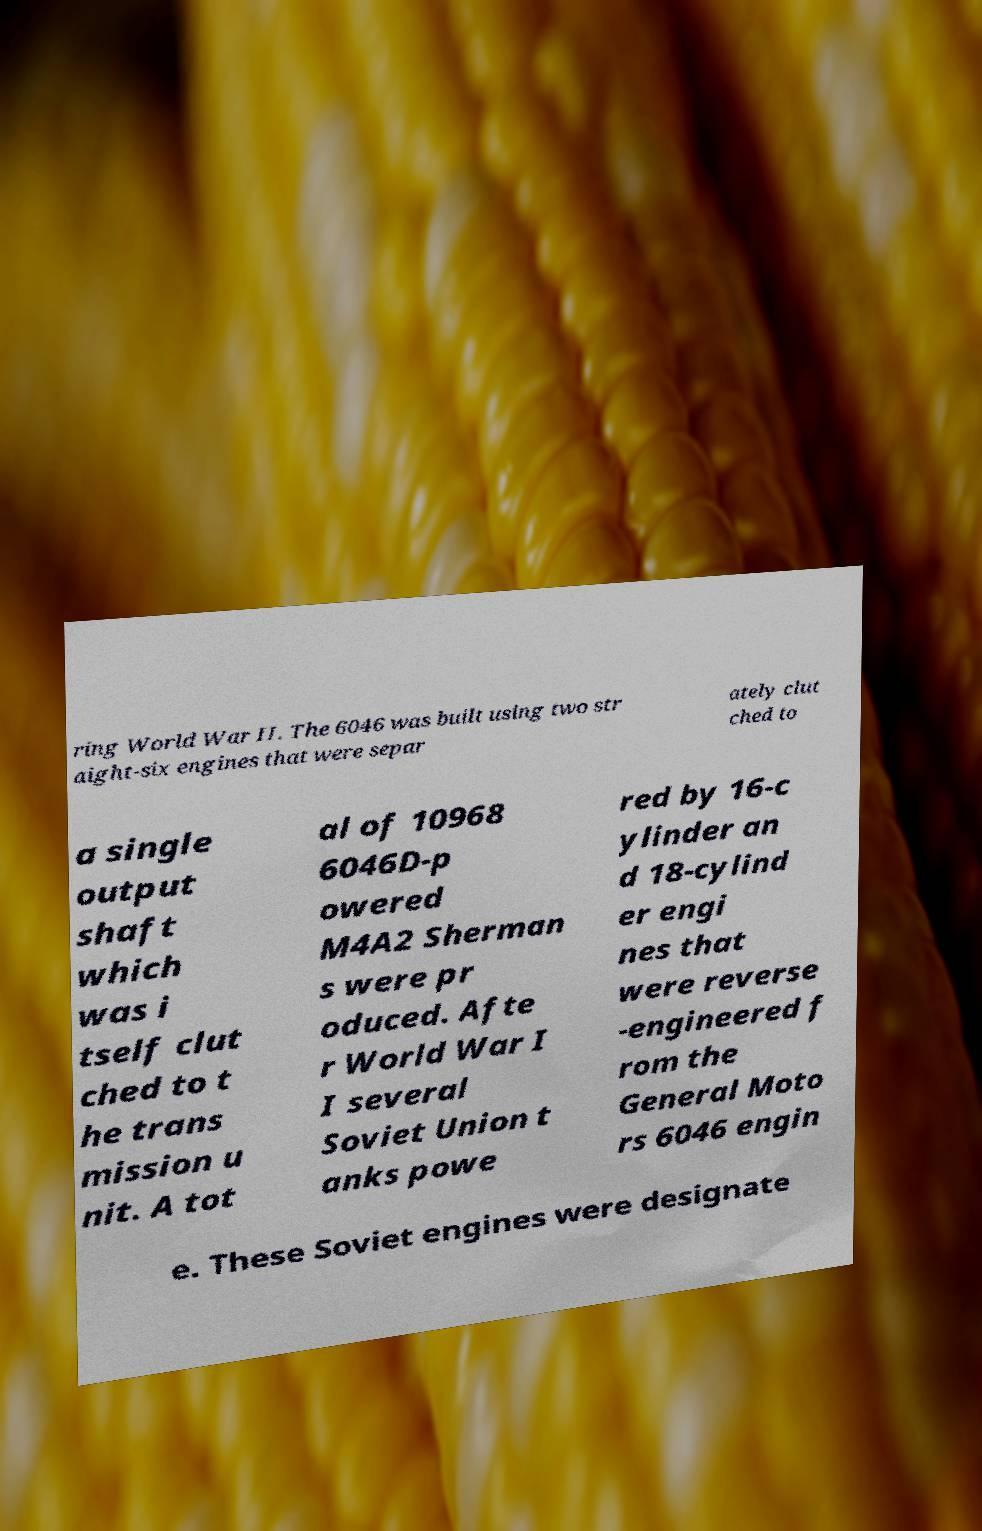What messages or text are displayed in this image? I need them in a readable, typed format. ring World War II. The 6046 was built using two str aight-six engines that were separ ately clut ched to a single output shaft which was i tself clut ched to t he trans mission u nit. A tot al of 10968 6046D-p owered M4A2 Sherman s were pr oduced. Afte r World War I I several Soviet Union t anks powe red by 16-c ylinder an d 18-cylind er engi nes that were reverse -engineered f rom the General Moto rs 6046 engin e. These Soviet engines were designate 